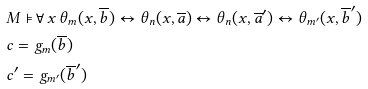<formula> <loc_0><loc_0><loc_500><loc_500>& M \models \forall \, x \, \theta _ { m } ( x , \overline { b } ) \leftrightarrow \theta _ { n } ( x , \overline { a } ) \leftrightarrow \theta _ { n } ( x , \overline { a } ^ { \prime } ) \leftrightarrow \theta _ { m ^ { \prime } } ( x , \overline { b } ^ { \prime } ) \\ & c = g _ { m } ( \overline { b } ) \\ & c ^ { \prime } = g _ { m ^ { \prime } } ( \overline { b } ^ { \prime } )</formula> 